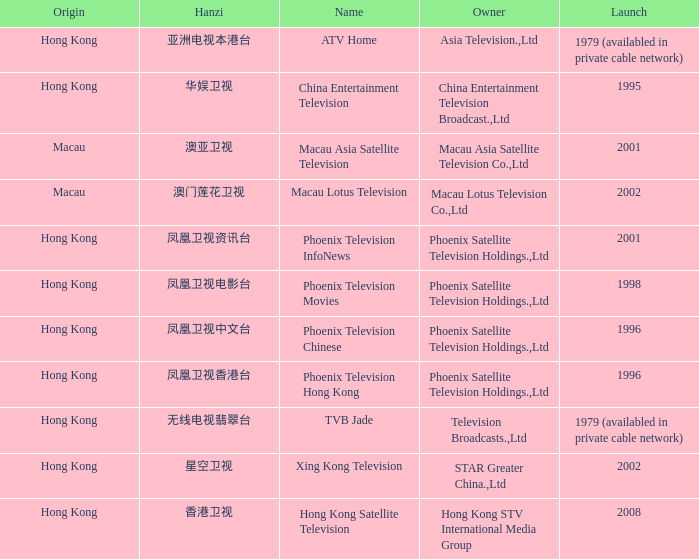What is the Hanzi of Hong Kong in 1998? 凤凰卫视电影台. 